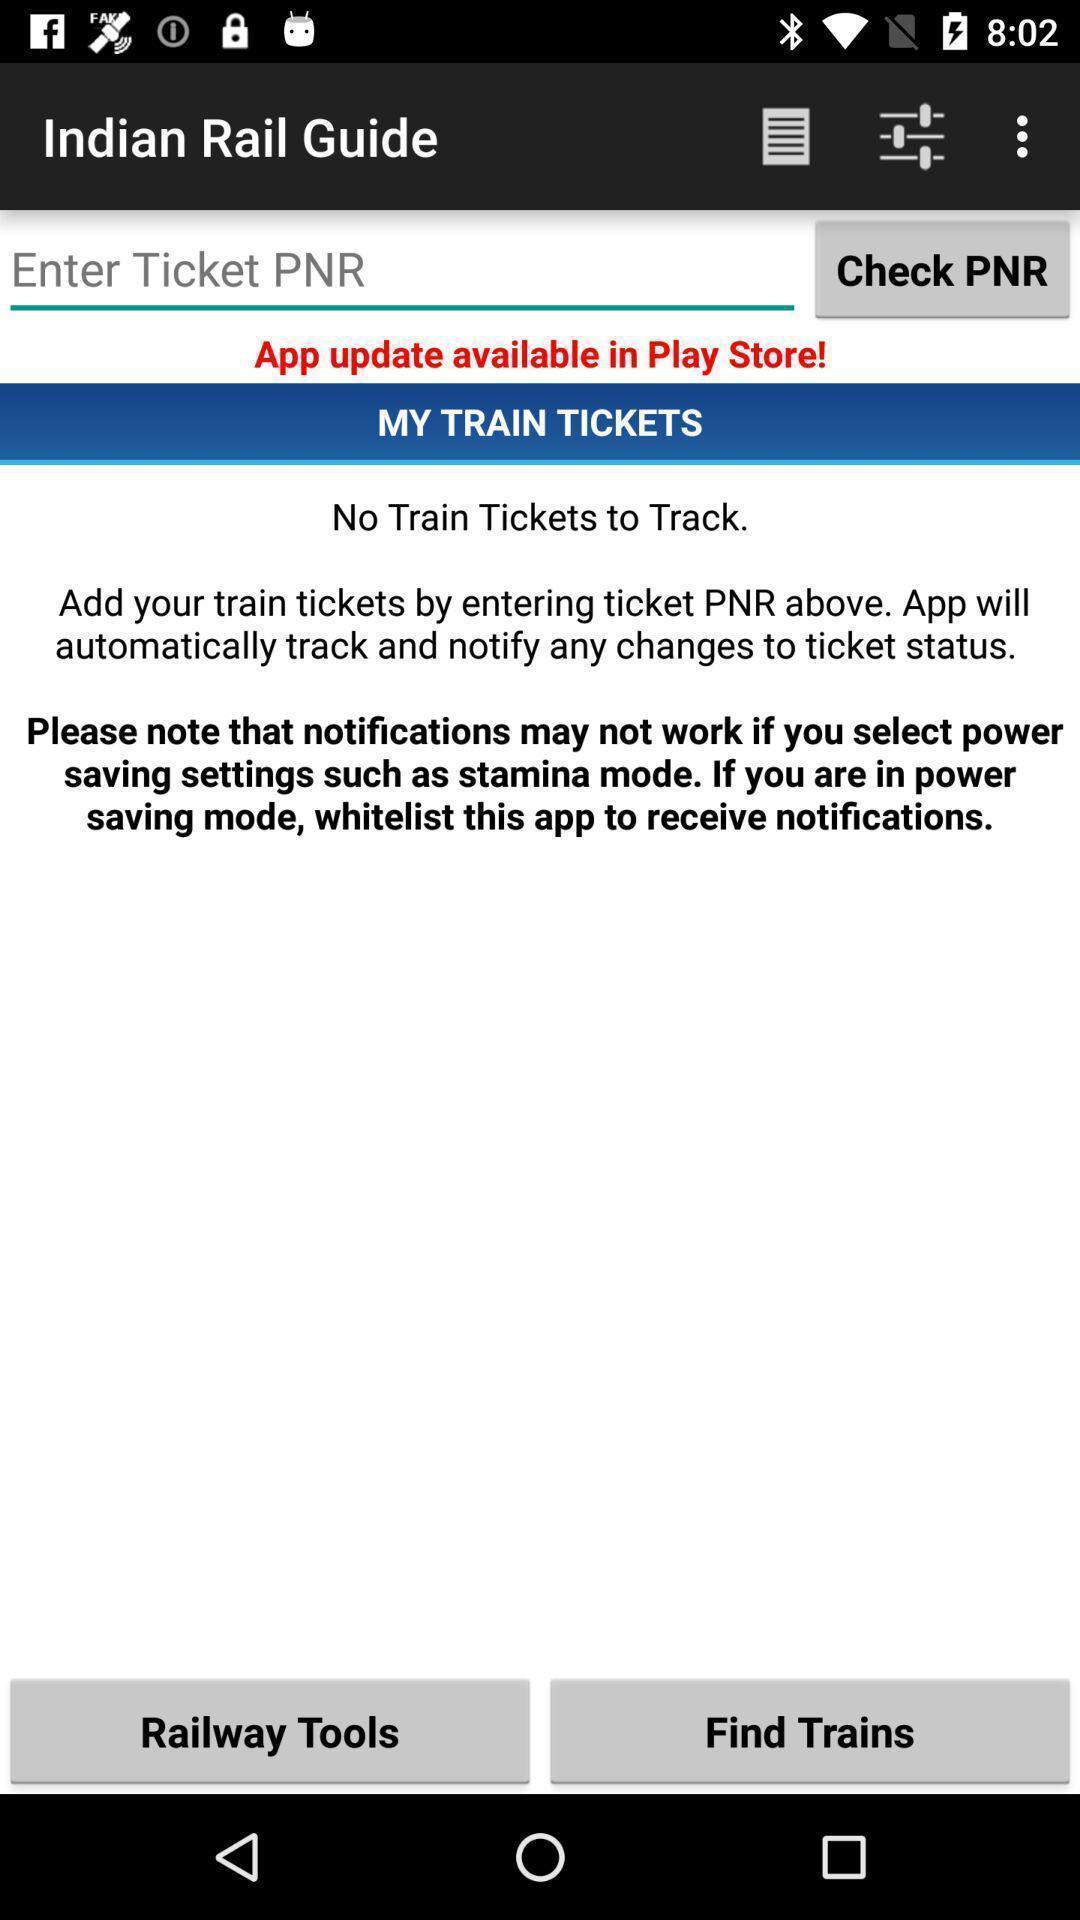Provide a detailed account of this screenshot. Page showing no availability of tickets in a travel app. 